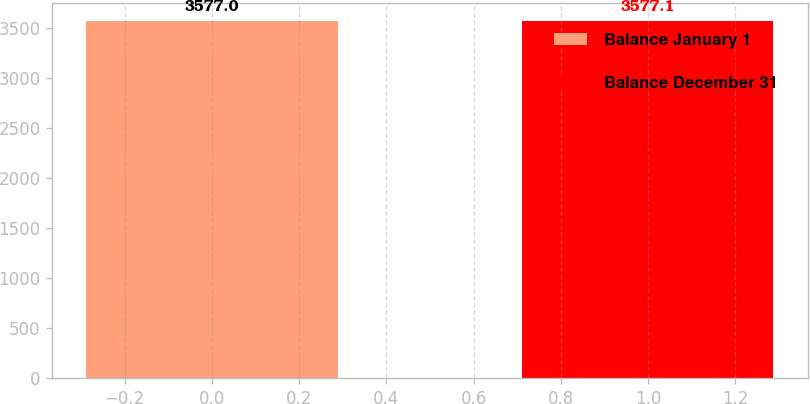Convert chart. <chart><loc_0><loc_0><loc_500><loc_500><bar_chart><fcel>Balance January 1<fcel>Balance December 31<nl><fcel>3577<fcel>3577.1<nl></chart> 